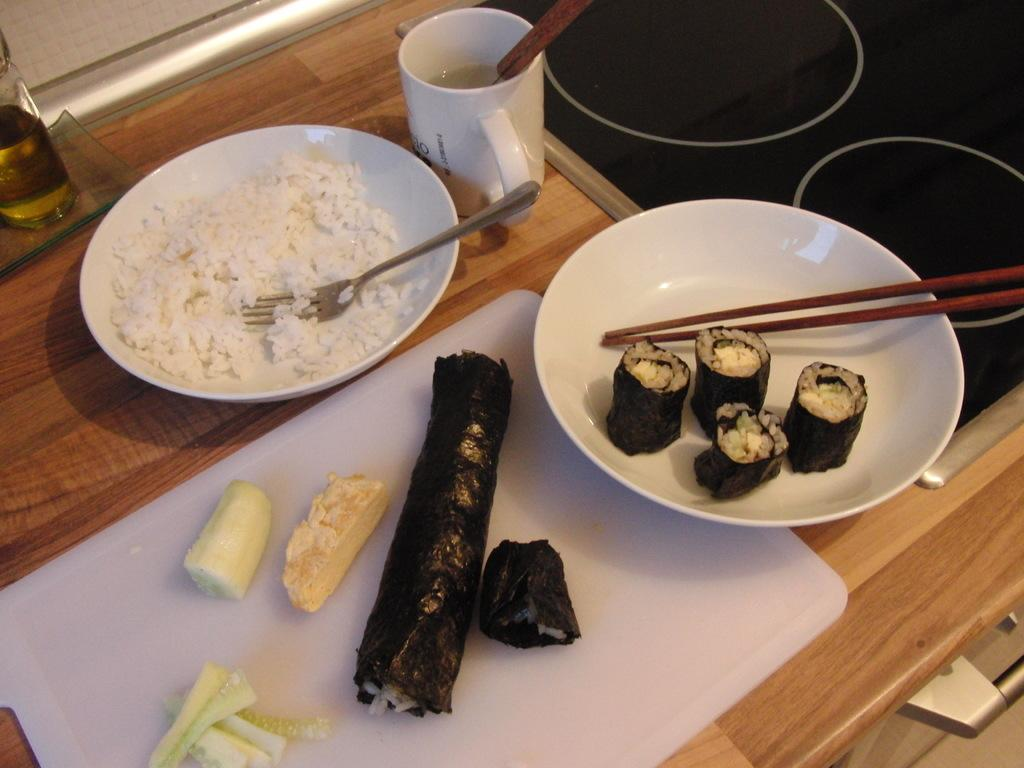What piece of furniture is present in the image? There is a table in the image. What type of food is on the plate on the table? There is a plate with rice on the table. What utensil is placed on the plate with rice? There is a fork on the plate. What other food item is present in the image? There is a tray with salad in it and another tray with chopsticks and food. What condiment is visible on the table? There is a bottle with oil at the left side corner of the table. What type of songs can be heard in the background of the image? There is no audio or music present in the image, so it is not possible to determine what songs might be heard. 